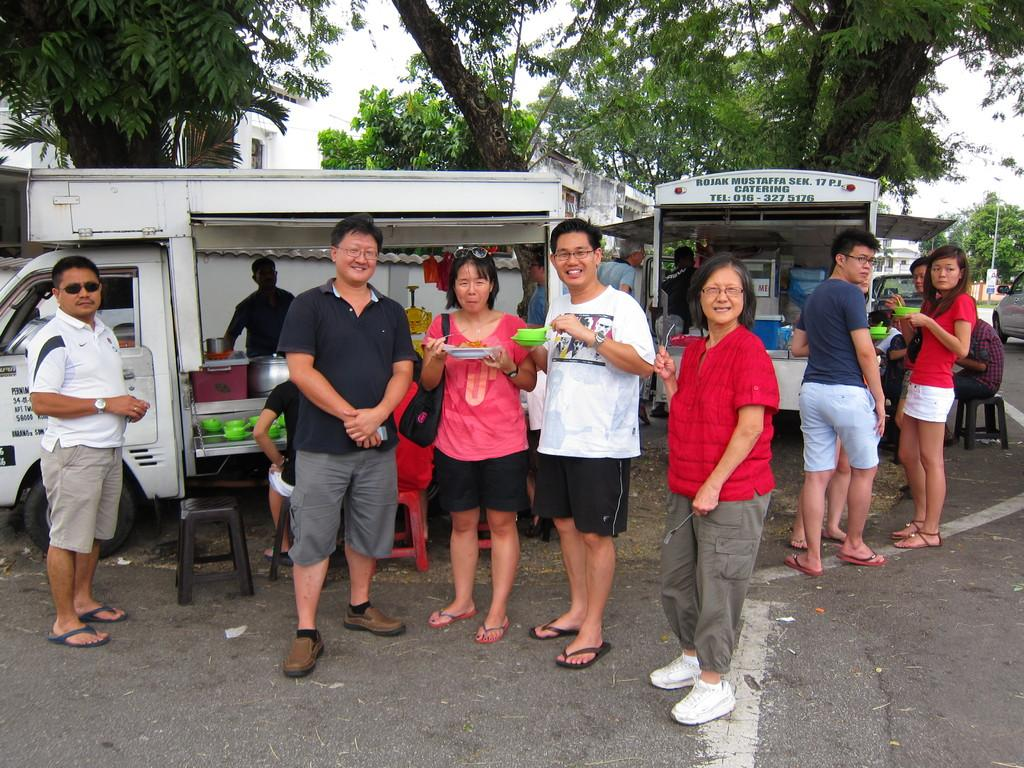How many people are in the image? There are people in the image, but the exact number is not specified. What are some people doing in the image? Some people are holding objects in the image. What can be seen in the background of the image? There are vehicles, trees, and a building in the background of the image. What type of furniture is present in the image? There are chairs in the image. What type of friends are depicted in the image? There is no mention of friends in the image, as the facts only mention people holding objects. What kind of loss is being experienced by the people in the image? There is no indication of any loss being experienced by the people in the image. 